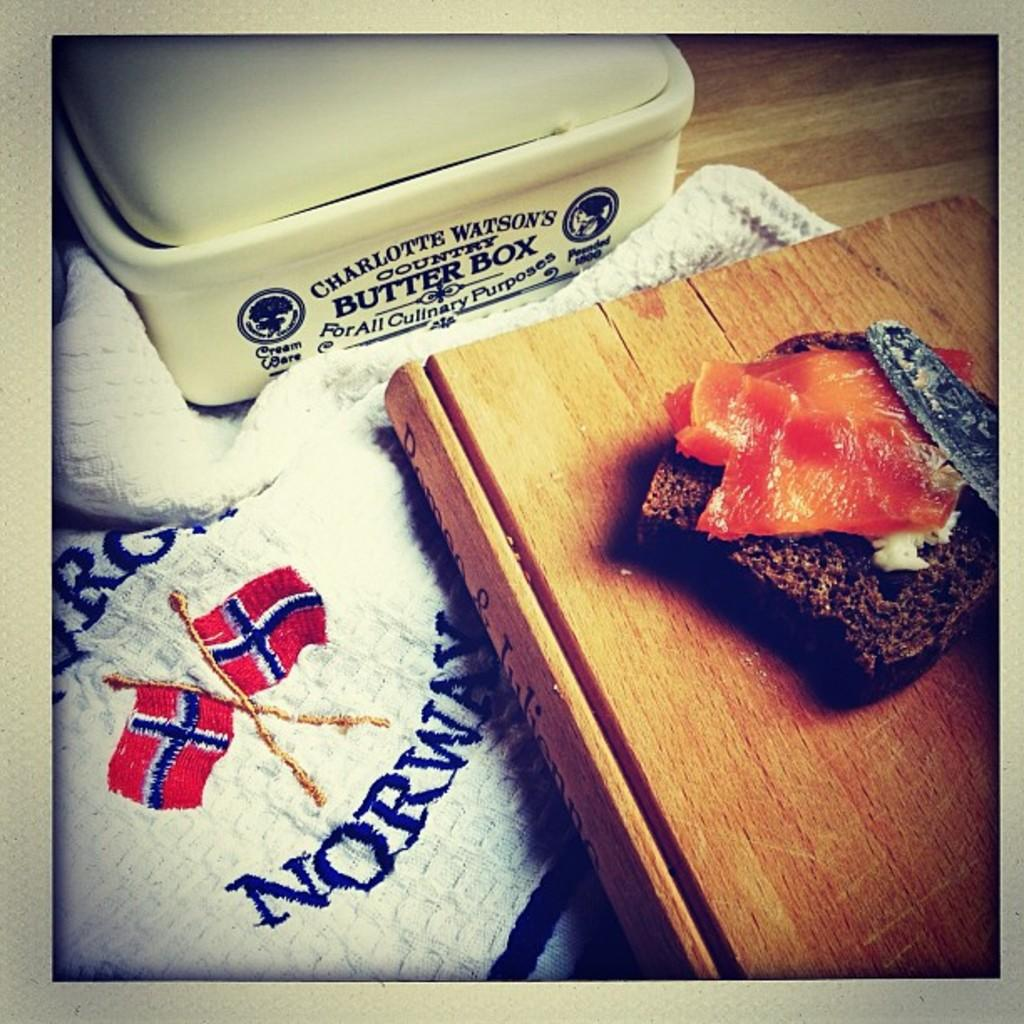What type of bread is visible in the image? There is a brown bread in the image. What utensil is present in the image? There is a knife in the image. What surface are the other ingredients placed on? The other ingredients are on a wooden board. What is the color of the box in the image? There is a white box in the image. What is the color and material of the cloth in the image? There is a white cloth in the image. How does the idea of driving relate to the image? The image does not depict any vehicles or driving-related elements, so the idea of driving is not relevant to the image. 